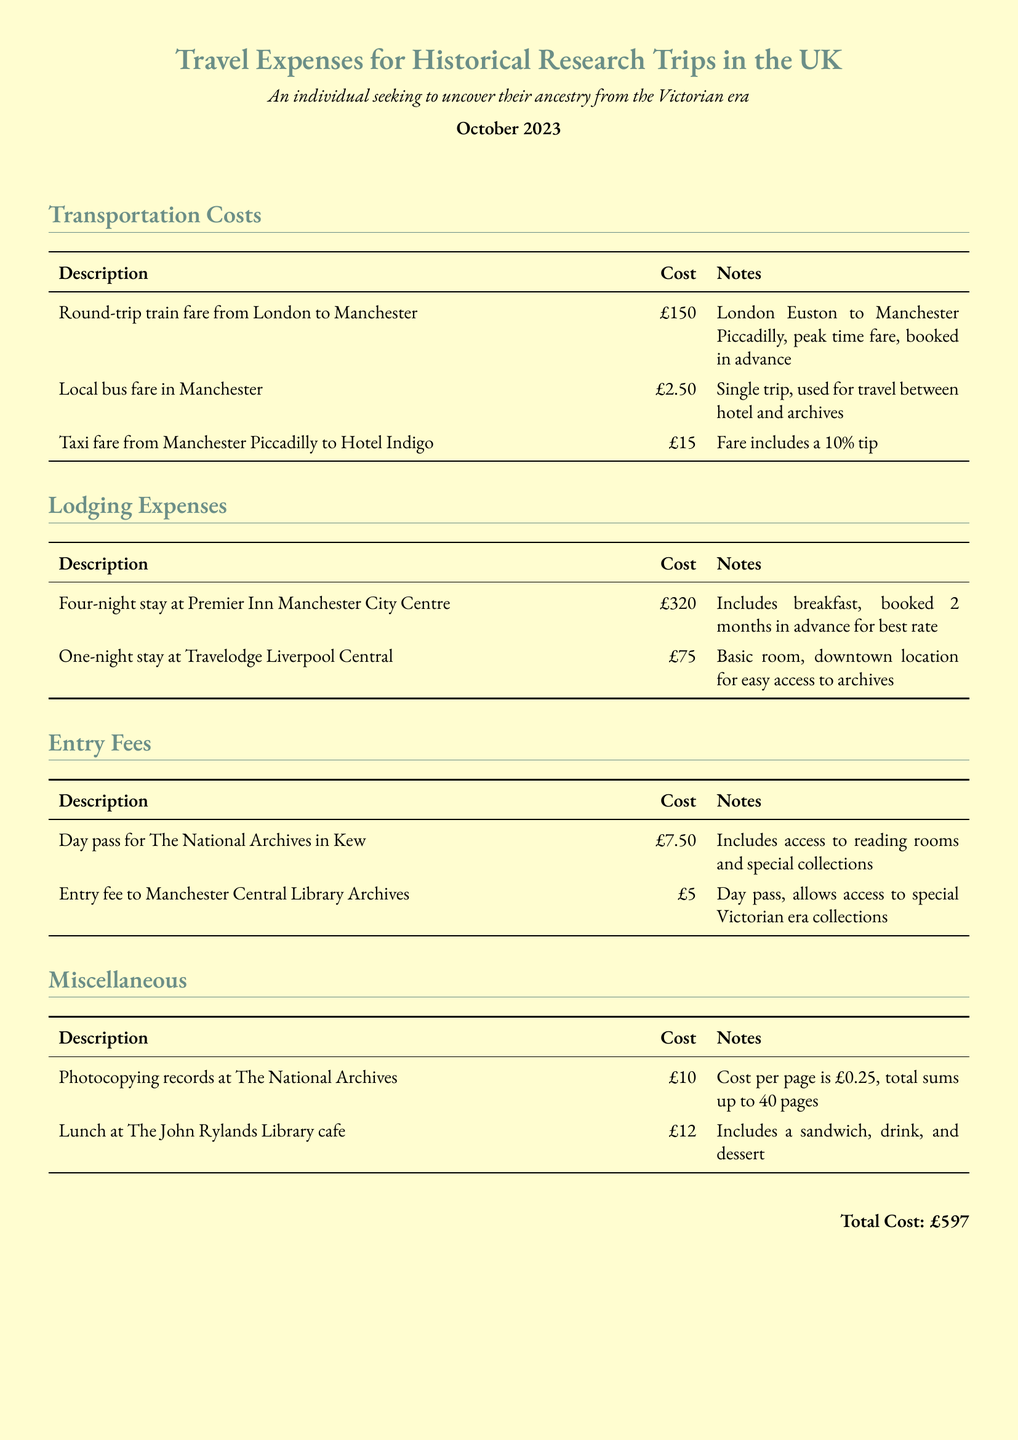What is the total cost of the trip? The total cost is stated at the bottom of the document as the sum of all expenses listed throughout the report.
Answer: £597 How much was spent on lodging? The lodging expenses are detailed in their own section, requiring the summation of all listed lodging costs.
Answer: £395 What was the local bus fare in Manchester? The document provides specific prices for each transportation method, including the local bus fare.
Answer: £2.50 What was the cost of the day pass for The National Archives? This is indicated within the Entry Fees section, specifying the cost for access to the archives.
Answer: £7.50 How many nights did the individual stay at the Premier Inn? The number of nights is explicitly mentioned in the lodging expenses section of the report.
Answer: Four nights What percentage tip was included in the taxi fare? Detailed notes about the taxi fare mention the inclusion of a tip, specifying its percentage.
Answer: 10% What was the entry fee to the Manchester Central Library Archives? This is specifically noted in the Entry Fees section of the document.
Answer: £5 What was the cost per page for photocopying at The National Archives? The cost for photocopying is detailed in the miscellaneous section, including the price per page.
Answer: £0.25 How long before the trip was the lodging booked for the Premier Inn? The document notes the advance booking time for lodging rates specifically for the Premier Inn.
Answer: 2 months 